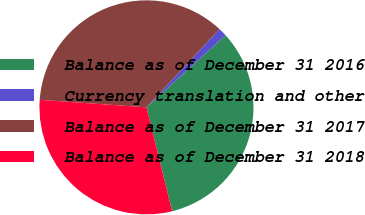Convert chart. <chart><loc_0><loc_0><loc_500><loc_500><pie_chart><fcel>Balance as of December 31 2016<fcel>Currency translation and other<fcel>Balance as of December 31 2017<fcel>Balance as of December 31 2018<nl><fcel>32.9%<fcel>1.3%<fcel>35.82%<fcel>29.98%<nl></chart> 